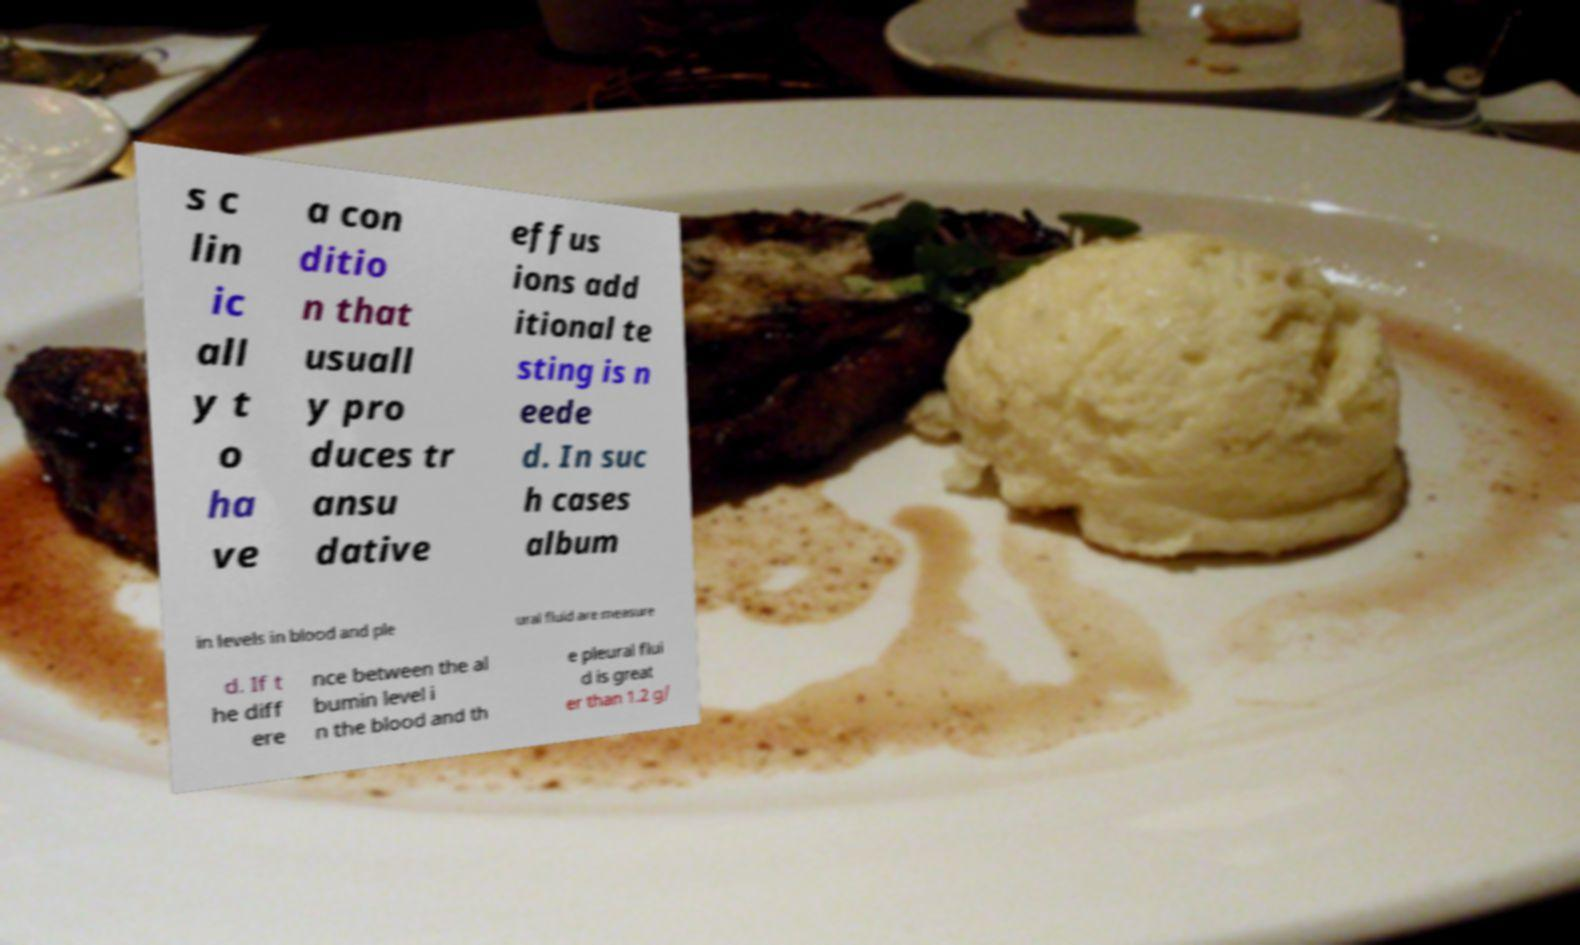Please read and relay the text visible in this image. What does it say? s c lin ic all y t o ha ve a con ditio n that usuall y pro duces tr ansu dative effus ions add itional te sting is n eede d. In suc h cases album in levels in blood and ple ural fluid are measure d. If t he diff ere nce between the al bumin level i n the blood and th e pleural flui d is great er than 1.2 g/ 